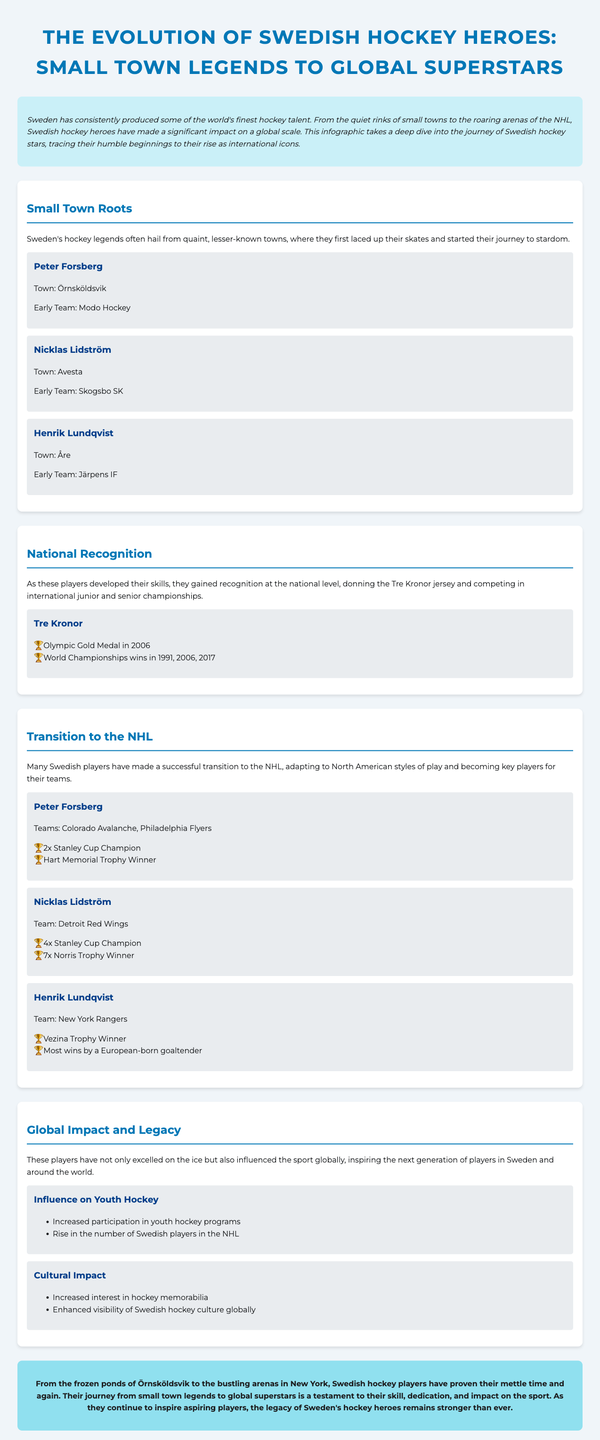What town is Peter Forsberg from? Peter Forsberg's early career began in Örnsköldsvik, as noted in the document.
Answer: Örnsköldsvik How many Stanley Cup Championships did Nicklas Lidström win? The document states Nicklas Lidström won 4 Stanley Cup Championships during his career.
Answer: 4 Which team did Henrik Lundqvist play for in the NHL? The document clearly identifies the New York Rangers as Henrik Lundqvist's NHL team.
Answer: New York Rangers What year did Tre Kronor win Olympic Gold? The document mentions that Tre Kronor won Olympic Gold in the year 2006.
Answer: 2006 Name one influence Swedish hockey players had on youth hockey. The document lists increased participation in youth hockey programs as one influence.
Answer: Increased participation What is the cultural impact mentioned in the document? The document highlights the increased interest in hockey memorabilia as a cultural impact from Swedish hockey players.
Answer: Increased interest in hockey memorabilia Which player is associated with the Hart Memorial Trophy? According to the document, Peter Forsberg won the Hart Memorial Trophy during his career.
Answer: Peter Forsberg What is the significance of the journey from small towns to global superstars? The document emphasizes the dedication and skill these players exhibited on their path to global stardom.
Answer: Dedication and skill How many Norris Trophies did Nicklas Lidström win? The document indicates that Nicklas Lidström was a 7-time Norris Trophy winner.
Answer: 7 